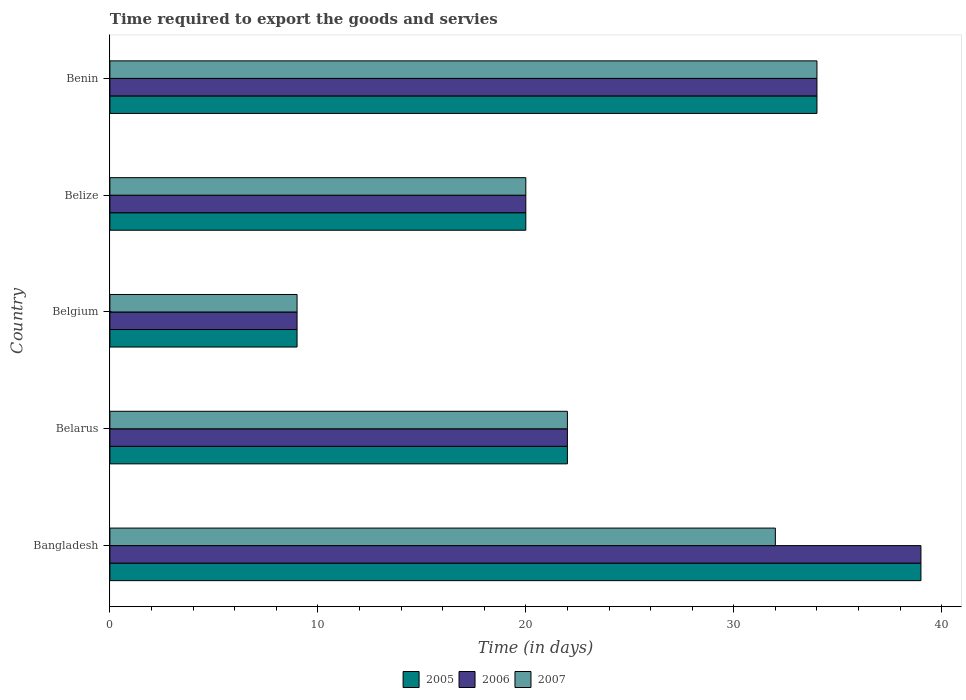How many different coloured bars are there?
Offer a very short reply. 3. Are the number of bars per tick equal to the number of legend labels?
Offer a terse response. Yes. Are the number of bars on each tick of the Y-axis equal?
Provide a succinct answer. Yes. How many bars are there on the 1st tick from the top?
Ensure brevity in your answer.  3. How many bars are there on the 5th tick from the bottom?
Your response must be concise. 3. What is the label of the 2nd group of bars from the top?
Offer a very short reply. Belize. In how many cases, is the number of bars for a given country not equal to the number of legend labels?
Offer a terse response. 0. What is the number of days required to export the goods and services in 2007 in Bangladesh?
Offer a very short reply. 32. Across all countries, what is the maximum number of days required to export the goods and services in 2005?
Offer a very short reply. 39. Across all countries, what is the minimum number of days required to export the goods and services in 2007?
Make the answer very short. 9. What is the total number of days required to export the goods and services in 2007 in the graph?
Ensure brevity in your answer.  117. What is the average number of days required to export the goods and services in 2005 per country?
Ensure brevity in your answer.  24.8. What is the ratio of the number of days required to export the goods and services in 2007 in Belarus to that in Belgium?
Keep it short and to the point. 2.44. What is the difference between the highest and the lowest number of days required to export the goods and services in 2005?
Offer a very short reply. 30. Is the sum of the number of days required to export the goods and services in 2006 in Belarus and Belgium greater than the maximum number of days required to export the goods and services in 2007 across all countries?
Your answer should be compact. No. What does the 3rd bar from the top in Benin represents?
Give a very brief answer. 2005. How many bars are there?
Ensure brevity in your answer.  15. How many countries are there in the graph?
Offer a terse response. 5. What is the difference between two consecutive major ticks on the X-axis?
Offer a very short reply. 10. Where does the legend appear in the graph?
Offer a very short reply. Bottom center. How many legend labels are there?
Ensure brevity in your answer.  3. How are the legend labels stacked?
Provide a succinct answer. Horizontal. What is the title of the graph?
Keep it short and to the point. Time required to export the goods and servies. Does "1973" appear as one of the legend labels in the graph?
Your answer should be very brief. No. What is the label or title of the X-axis?
Give a very brief answer. Time (in days). What is the Time (in days) of 2006 in Bangladesh?
Your answer should be compact. 39. What is the Time (in days) of 2006 in Belarus?
Offer a very short reply. 22. What is the Time (in days) of 2007 in Belarus?
Your response must be concise. 22. What is the Time (in days) of 2007 in Belgium?
Provide a succinct answer. 9. What is the Time (in days) of 2006 in Belize?
Offer a very short reply. 20. What is the Time (in days) in 2005 in Benin?
Give a very brief answer. 34. What is the Time (in days) of 2006 in Benin?
Give a very brief answer. 34. Across all countries, what is the maximum Time (in days) in 2005?
Give a very brief answer. 39. Across all countries, what is the maximum Time (in days) in 2007?
Offer a very short reply. 34. Across all countries, what is the minimum Time (in days) in 2005?
Give a very brief answer. 9. Across all countries, what is the minimum Time (in days) in 2006?
Your answer should be compact. 9. What is the total Time (in days) in 2005 in the graph?
Ensure brevity in your answer.  124. What is the total Time (in days) of 2006 in the graph?
Your answer should be compact. 124. What is the total Time (in days) in 2007 in the graph?
Offer a very short reply. 117. What is the difference between the Time (in days) of 2005 in Bangladesh and that in Belarus?
Offer a very short reply. 17. What is the difference between the Time (in days) of 2006 in Bangladesh and that in Belarus?
Give a very brief answer. 17. What is the difference between the Time (in days) of 2007 in Bangladesh and that in Belarus?
Your response must be concise. 10. What is the difference between the Time (in days) of 2006 in Bangladesh and that in Belgium?
Your answer should be compact. 30. What is the difference between the Time (in days) in 2007 in Bangladesh and that in Belgium?
Your response must be concise. 23. What is the difference between the Time (in days) in 2005 in Bangladesh and that in Belize?
Offer a terse response. 19. What is the difference between the Time (in days) of 2006 in Bangladesh and that in Belize?
Offer a terse response. 19. What is the difference between the Time (in days) in 2007 in Bangladesh and that in Belize?
Provide a short and direct response. 12. What is the difference between the Time (in days) of 2005 in Bangladesh and that in Benin?
Your answer should be very brief. 5. What is the difference between the Time (in days) of 2007 in Bangladesh and that in Benin?
Offer a terse response. -2. What is the difference between the Time (in days) of 2007 in Belarus and that in Belgium?
Your answer should be compact. 13. What is the difference between the Time (in days) in 2005 in Belarus and that in Belize?
Your answer should be very brief. 2. What is the difference between the Time (in days) of 2006 in Belarus and that in Benin?
Give a very brief answer. -12. What is the difference between the Time (in days) of 2007 in Belarus and that in Benin?
Keep it short and to the point. -12. What is the difference between the Time (in days) of 2005 in Belgium and that in Belize?
Keep it short and to the point. -11. What is the difference between the Time (in days) of 2006 in Belgium and that in Belize?
Make the answer very short. -11. What is the difference between the Time (in days) of 2006 in Belgium and that in Benin?
Provide a succinct answer. -25. What is the difference between the Time (in days) of 2007 in Belgium and that in Benin?
Make the answer very short. -25. What is the difference between the Time (in days) in 2006 in Bangladesh and the Time (in days) in 2007 in Belarus?
Provide a succinct answer. 17. What is the difference between the Time (in days) of 2005 in Bangladesh and the Time (in days) of 2006 in Belgium?
Provide a short and direct response. 30. What is the difference between the Time (in days) in 2006 in Bangladesh and the Time (in days) in 2007 in Belgium?
Your response must be concise. 30. What is the difference between the Time (in days) in 2005 in Bangladesh and the Time (in days) in 2006 in Belize?
Offer a very short reply. 19. What is the difference between the Time (in days) in 2005 in Bangladesh and the Time (in days) in 2007 in Belize?
Provide a succinct answer. 19. What is the difference between the Time (in days) of 2005 in Bangladesh and the Time (in days) of 2006 in Benin?
Provide a short and direct response. 5. What is the difference between the Time (in days) of 2005 in Bangladesh and the Time (in days) of 2007 in Benin?
Ensure brevity in your answer.  5. What is the difference between the Time (in days) in 2006 in Bangladesh and the Time (in days) in 2007 in Benin?
Provide a succinct answer. 5. What is the difference between the Time (in days) in 2005 in Belarus and the Time (in days) in 2006 in Belgium?
Your answer should be very brief. 13. What is the difference between the Time (in days) in 2005 in Belarus and the Time (in days) in 2007 in Belgium?
Offer a terse response. 13. What is the difference between the Time (in days) in 2005 in Belarus and the Time (in days) in 2006 in Belize?
Your answer should be very brief. 2. What is the difference between the Time (in days) in 2005 in Belarus and the Time (in days) in 2007 in Belize?
Your answer should be very brief. 2. What is the difference between the Time (in days) of 2006 in Belarus and the Time (in days) of 2007 in Belize?
Give a very brief answer. 2. What is the difference between the Time (in days) in 2005 in Belarus and the Time (in days) in 2007 in Benin?
Provide a succinct answer. -12. What is the difference between the Time (in days) in 2006 in Belarus and the Time (in days) in 2007 in Benin?
Provide a succinct answer. -12. What is the difference between the Time (in days) in 2005 in Belgium and the Time (in days) in 2006 in Belize?
Give a very brief answer. -11. What is the difference between the Time (in days) in 2005 in Belgium and the Time (in days) in 2007 in Belize?
Your response must be concise. -11. What is the difference between the Time (in days) of 2005 in Belgium and the Time (in days) of 2006 in Benin?
Give a very brief answer. -25. What is the difference between the Time (in days) of 2005 in Belgium and the Time (in days) of 2007 in Benin?
Make the answer very short. -25. What is the difference between the Time (in days) of 2006 in Belgium and the Time (in days) of 2007 in Benin?
Provide a succinct answer. -25. What is the difference between the Time (in days) in 2005 in Belize and the Time (in days) in 2007 in Benin?
Your response must be concise. -14. What is the average Time (in days) of 2005 per country?
Keep it short and to the point. 24.8. What is the average Time (in days) in 2006 per country?
Your answer should be compact. 24.8. What is the average Time (in days) of 2007 per country?
Provide a short and direct response. 23.4. What is the difference between the Time (in days) of 2006 and Time (in days) of 2007 in Bangladesh?
Your answer should be very brief. 7. What is the difference between the Time (in days) of 2005 and Time (in days) of 2006 in Belgium?
Make the answer very short. 0. What is the difference between the Time (in days) in 2005 and Time (in days) in 2007 in Belize?
Make the answer very short. 0. What is the difference between the Time (in days) of 2005 and Time (in days) of 2006 in Benin?
Your answer should be very brief. 0. What is the difference between the Time (in days) in 2006 and Time (in days) in 2007 in Benin?
Offer a very short reply. 0. What is the ratio of the Time (in days) of 2005 in Bangladesh to that in Belarus?
Provide a succinct answer. 1.77. What is the ratio of the Time (in days) of 2006 in Bangladesh to that in Belarus?
Ensure brevity in your answer.  1.77. What is the ratio of the Time (in days) in 2007 in Bangladesh to that in Belarus?
Your answer should be compact. 1.45. What is the ratio of the Time (in days) of 2005 in Bangladesh to that in Belgium?
Provide a short and direct response. 4.33. What is the ratio of the Time (in days) in 2006 in Bangladesh to that in Belgium?
Provide a short and direct response. 4.33. What is the ratio of the Time (in days) in 2007 in Bangladesh to that in Belgium?
Keep it short and to the point. 3.56. What is the ratio of the Time (in days) of 2005 in Bangladesh to that in Belize?
Provide a short and direct response. 1.95. What is the ratio of the Time (in days) of 2006 in Bangladesh to that in Belize?
Your answer should be very brief. 1.95. What is the ratio of the Time (in days) in 2005 in Bangladesh to that in Benin?
Ensure brevity in your answer.  1.15. What is the ratio of the Time (in days) of 2006 in Bangladesh to that in Benin?
Keep it short and to the point. 1.15. What is the ratio of the Time (in days) in 2005 in Belarus to that in Belgium?
Your answer should be very brief. 2.44. What is the ratio of the Time (in days) in 2006 in Belarus to that in Belgium?
Offer a very short reply. 2.44. What is the ratio of the Time (in days) of 2007 in Belarus to that in Belgium?
Make the answer very short. 2.44. What is the ratio of the Time (in days) of 2006 in Belarus to that in Belize?
Offer a very short reply. 1.1. What is the ratio of the Time (in days) of 2007 in Belarus to that in Belize?
Provide a succinct answer. 1.1. What is the ratio of the Time (in days) in 2005 in Belarus to that in Benin?
Ensure brevity in your answer.  0.65. What is the ratio of the Time (in days) in 2006 in Belarus to that in Benin?
Keep it short and to the point. 0.65. What is the ratio of the Time (in days) in 2007 in Belarus to that in Benin?
Provide a short and direct response. 0.65. What is the ratio of the Time (in days) in 2005 in Belgium to that in Belize?
Offer a very short reply. 0.45. What is the ratio of the Time (in days) of 2006 in Belgium to that in Belize?
Your answer should be very brief. 0.45. What is the ratio of the Time (in days) of 2007 in Belgium to that in Belize?
Provide a short and direct response. 0.45. What is the ratio of the Time (in days) of 2005 in Belgium to that in Benin?
Your answer should be very brief. 0.26. What is the ratio of the Time (in days) of 2006 in Belgium to that in Benin?
Offer a very short reply. 0.26. What is the ratio of the Time (in days) of 2007 in Belgium to that in Benin?
Ensure brevity in your answer.  0.26. What is the ratio of the Time (in days) of 2005 in Belize to that in Benin?
Offer a very short reply. 0.59. What is the ratio of the Time (in days) of 2006 in Belize to that in Benin?
Ensure brevity in your answer.  0.59. What is the ratio of the Time (in days) of 2007 in Belize to that in Benin?
Your answer should be very brief. 0.59. What is the difference between the highest and the second highest Time (in days) of 2007?
Make the answer very short. 2. What is the difference between the highest and the lowest Time (in days) in 2007?
Make the answer very short. 25. 